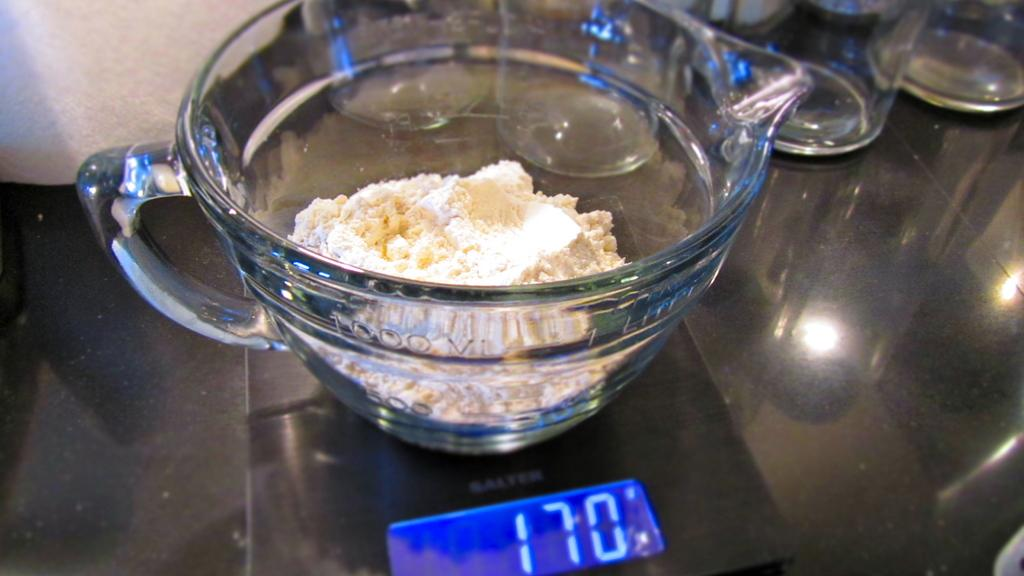<image>
Summarize the visual content of the image. A bowl of flour and butter on a stove set to 170 degrees. 